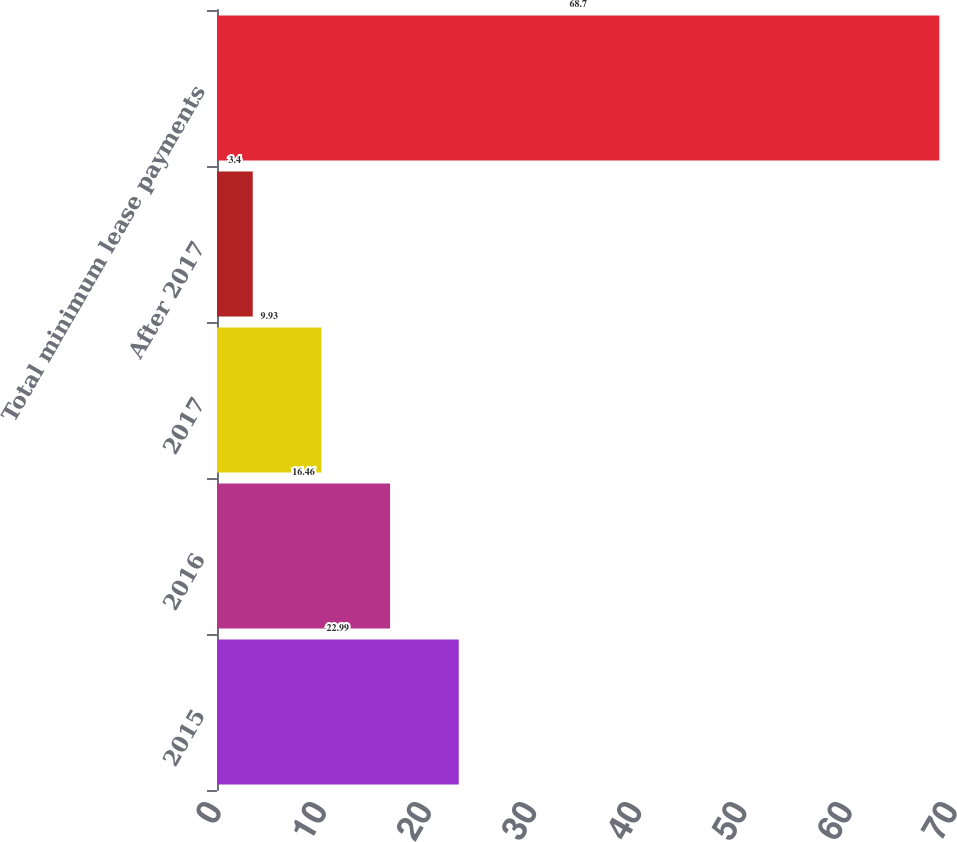<chart> <loc_0><loc_0><loc_500><loc_500><bar_chart><fcel>2015<fcel>2016<fcel>2017<fcel>After 2017<fcel>Total minimum lease payments<nl><fcel>22.99<fcel>16.46<fcel>9.93<fcel>3.4<fcel>68.7<nl></chart> 